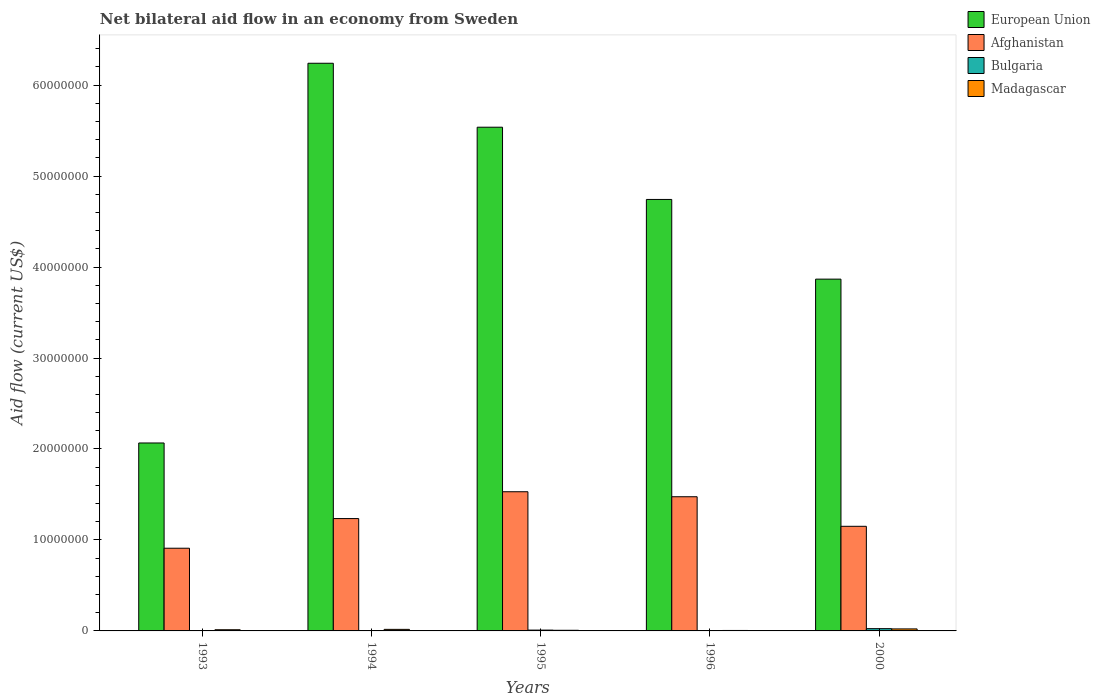Are the number of bars per tick equal to the number of legend labels?
Your answer should be very brief. Yes. How many bars are there on the 1st tick from the right?
Provide a short and direct response. 4. Across all years, what is the minimum net bilateral aid flow in Bulgaria?
Make the answer very short. 10000. In which year was the net bilateral aid flow in European Union maximum?
Offer a very short reply. 1994. What is the total net bilateral aid flow in Afghanistan in the graph?
Ensure brevity in your answer.  6.30e+07. What is the difference between the net bilateral aid flow in Bulgaria in 1994 and that in 2000?
Keep it short and to the point. -2.30e+05. What is the difference between the net bilateral aid flow in European Union in 1993 and the net bilateral aid flow in Bulgaria in 1994?
Offer a very short reply. 2.06e+07. What is the average net bilateral aid flow in Afghanistan per year?
Your answer should be very brief. 1.26e+07. In the year 1994, what is the difference between the net bilateral aid flow in European Union and net bilateral aid flow in Afghanistan?
Give a very brief answer. 5.00e+07. In how many years, is the net bilateral aid flow in Bulgaria greater than 52000000 US$?
Offer a terse response. 0. What is the ratio of the net bilateral aid flow in Madagascar in 1994 to that in 1996?
Your answer should be very brief. 3.4. Is the net bilateral aid flow in European Union in 1994 less than that in 1995?
Your answer should be very brief. No. Is the difference between the net bilateral aid flow in European Union in 1994 and 1996 greater than the difference between the net bilateral aid flow in Afghanistan in 1994 and 1996?
Offer a very short reply. Yes. What is the difference between the highest and the second highest net bilateral aid flow in European Union?
Offer a very short reply. 7.03e+06. What is the difference between the highest and the lowest net bilateral aid flow in Afghanistan?
Your answer should be very brief. 6.21e+06. In how many years, is the net bilateral aid flow in European Union greater than the average net bilateral aid flow in European Union taken over all years?
Ensure brevity in your answer.  3. Is it the case that in every year, the sum of the net bilateral aid flow in Bulgaria and net bilateral aid flow in Afghanistan is greater than the sum of net bilateral aid flow in Madagascar and net bilateral aid flow in European Union?
Your answer should be very brief. No. What does the 2nd bar from the left in 1994 represents?
Make the answer very short. Afghanistan. Are all the bars in the graph horizontal?
Give a very brief answer. No. Where does the legend appear in the graph?
Provide a short and direct response. Top right. How many legend labels are there?
Provide a short and direct response. 4. How are the legend labels stacked?
Your response must be concise. Vertical. What is the title of the graph?
Your answer should be very brief. Net bilateral aid flow in an economy from Sweden. What is the label or title of the X-axis?
Offer a terse response. Years. What is the label or title of the Y-axis?
Ensure brevity in your answer.  Aid flow (current US$). What is the Aid flow (current US$) of European Union in 1993?
Your response must be concise. 2.07e+07. What is the Aid flow (current US$) in Afghanistan in 1993?
Provide a succinct answer. 9.09e+06. What is the Aid flow (current US$) of Bulgaria in 1993?
Provide a short and direct response. 10000. What is the Aid flow (current US$) of Madagascar in 1993?
Your answer should be very brief. 1.30e+05. What is the Aid flow (current US$) of European Union in 1994?
Keep it short and to the point. 6.24e+07. What is the Aid flow (current US$) of Afghanistan in 1994?
Offer a terse response. 1.24e+07. What is the Aid flow (current US$) of European Union in 1995?
Make the answer very short. 5.54e+07. What is the Aid flow (current US$) of Afghanistan in 1995?
Keep it short and to the point. 1.53e+07. What is the Aid flow (current US$) of Madagascar in 1995?
Make the answer very short. 7.00e+04. What is the Aid flow (current US$) in European Union in 1996?
Your answer should be very brief. 4.74e+07. What is the Aid flow (current US$) in Afghanistan in 1996?
Make the answer very short. 1.48e+07. What is the Aid flow (current US$) in Madagascar in 1996?
Ensure brevity in your answer.  5.00e+04. What is the Aid flow (current US$) of European Union in 2000?
Give a very brief answer. 3.87e+07. What is the Aid flow (current US$) of Afghanistan in 2000?
Provide a short and direct response. 1.15e+07. What is the Aid flow (current US$) in Madagascar in 2000?
Give a very brief answer. 2.20e+05. Across all years, what is the maximum Aid flow (current US$) in European Union?
Give a very brief answer. 6.24e+07. Across all years, what is the maximum Aid flow (current US$) of Afghanistan?
Give a very brief answer. 1.53e+07. Across all years, what is the maximum Aid flow (current US$) in Bulgaria?
Give a very brief answer. 2.50e+05. Across all years, what is the minimum Aid flow (current US$) in European Union?
Your answer should be very brief. 2.07e+07. Across all years, what is the minimum Aid flow (current US$) of Afghanistan?
Give a very brief answer. 9.09e+06. Across all years, what is the minimum Aid flow (current US$) of Bulgaria?
Provide a succinct answer. 10000. Across all years, what is the minimum Aid flow (current US$) of Madagascar?
Provide a short and direct response. 5.00e+04. What is the total Aid flow (current US$) in European Union in the graph?
Offer a terse response. 2.25e+08. What is the total Aid flow (current US$) of Afghanistan in the graph?
Keep it short and to the point. 6.30e+07. What is the total Aid flow (current US$) in Madagascar in the graph?
Offer a terse response. 6.40e+05. What is the difference between the Aid flow (current US$) of European Union in 1993 and that in 1994?
Your answer should be compact. -4.17e+07. What is the difference between the Aid flow (current US$) in Afghanistan in 1993 and that in 1994?
Your response must be concise. -3.26e+06. What is the difference between the Aid flow (current US$) of Bulgaria in 1993 and that in 1994?
Your answer should be compact. -10000. What is the difference between the Aid flow (current US$) of Madagascar in 1993 and that in 1994?
Offer a very short reply. -4.00e+04. What is the difference between the Aid flow (current US$) in European Union in 1993 and that in 1995?
Your answer should be very brief. -3.47e+07. What is the difference between the Aid flow (current US$) of Afghanistan in 1993 and that in 1995?
Keep it short and to the point. -6.21e+06. What is the difference between the Aid flow (current US$) of Madagascar in 1993 and that in 1995?
Your answer should be very brief. 6.00e+04. What is the difference between the Aid flow (current US$) in European Union in 1993 and that in 1996?
Provide a short and direct response. -2.68e+07. What is the difference between the Aid flow (current US$) in Afghanistan in 1993 and that in 1996?
Provide a short and direct response. -5.66e+06. What is the difference between the Aid flow (current US$) of Bulgaria in 1993 and that in 1996?
Offer a very short reply. 0. What is the difference between the Aid flow (current US$) in European Union in 1993 and that in 2000?
Ensure brevity in your answer.  -1.80e+07. What is the difference between the Aid flow (current US$) of Afghanistan in 1993 and that in 2000?
Offer a terse response. -2.41e+06. What is the difference between the Aid flow (current US$) of Bulgaria in 1993 and that in 2000?
Your answer should be compact. -2.40e+05. What is the difference between the Aid flow (current US$) in Madagascar in 1993 and that in 2000?
Give a very brief answer. -9.00e+04. What is the difference between the Aid flow (current US$) in European Union in 1994 and that in 1995?
Your response must be concise. 7.03e+06. What is the difference between the Aid flow (current US$) in Afghanistan in 1994 and that in 1995?
Your answer should be compact. -2.95e+06. What is the difference between the Aid flow (current US$) of Bulgaria in 1994 and that in 1995?
Provide a short and direct response. -7.00e+04. What is the difference between the Aid flow (current US$) in European Union in 1994 and that in 1996?
Your answer should be compact. 1.50e+07. What is the difference between the Aid flow (current US$) of Afghanistan in 1994 and that in 1996?
Provide a short and direct response. -2.40e+06. What is the difference between the Aid flow (current US$) in Bulgaria in 1994 and that in 1996?
Your answer should be compact. 10000. What is the difference between the Aid flow (current US$) in Madagascar in 1994 and that in 1996?
Keep it short and to the point. 1.20e+05. What is the difference between the Aid flow (current US$) in European Union in 1994 and that in 2000?
Your response must be concise. 2.37e+07. What is the difference between the Aid flow (current US$) in Afghanistan in 1994 and that in 2000?
Provide a short and direct response. 8.50e+05. What is the difference between the Aid flow (current US$) of Bulgaria in 1994 and that in 2000?
Your response must be concise. -2.30e+05. What is the difference between the Aid flow (current US$) in European Union in 1995 and that in 1996?
Provide a succinct answer. 7.94e+06. What is the difference between the Aid flow (current US$) of Madagascar in 1995 and that in 1996?
Offer a very short reply. 2.00e+04. What is the difference between the Aid flow (current US$) of European Union in 1995 and that in 2000?
Ensure brevity in your answer.  1.67e+07. What is the difference between the Aid flow (current US$) of Afghanistan in 1995 and that in 2000?
Provide a succinct answer. 3.80e+06. What is the difference between the Aid flow (current US$) of Bulgaria in 1995 and that in 2000?
Provide a succinct answer. -1.60e+05. What is the difference between the Aid flow (current US$) of Madagascar in 1995 and that in 2000?
Your answer should be very brief. -1.50e+05. What is the difference between the Aid flow (current US$) in European Union in 1996 and that in 2000?
Provide a short and direct response. 8.76e+06. What is the difference between the Aid flow (current US$) of Afghanistan in 1996 and that in 2000?
Give a very brief answer. 3.25e+06. What is the difference between the Aid flow (current US$) of European Union in 1993 and the Aid flow (current US$) of Afghanistan in 1994?
Make the answer very short. 8.31e+06. What is the difference between the Aid flow (current US$) in European Union in 1993 and the Aid flow (current US$) in Bulgaria in 1994?
Your answer should be compact. 2.06e+07. What is the difference between the Aid flow (current US$) of European Union in 1993 and the Aid flow (current US$) of Madagascar in 1994?
Your answer should be very brief. 2.05e+07. What is the difference between the Aid flow (current US$) of Afghanistan in 1993 and the Aid flow (current US$) of Bulgaria in 1994?
Provide a succinct answer. 9.07e+06. What is the difference between the Aid flow (current US$) in Afghanistan in 1993 and the Aid flow (current US$) in Madagascar in 1994?
Make the answer very short. 8.92e+06. What is the difference between the Aid flow (current US$) of Bulgaria in 1993 and the Aid flow (current US$) of Madagascar in 1994?
Offer a very short reply. -1.60e+05. What is the difference between the Aid flow (current US$) of European Union in 1993 and the Aid flow (current US$) of Afghanistan in 1995?
Your answer should be very brief. 5.36e+06. What is the difference between the Aid flow (current US$) in European Union in 1993 and the Aid flow (current US$) in Bulgaria in 1995?
Give a very brief answer. 2.06e+07. What is the difference between the Aid flow (current US$) of European Union in 1993 and the Aid flow (current US$) of Madagascar in 1995?
Offer a very short reply. 2.06e+07. What is the difference between the Aid flow (current US$) of Afghanistan in 1993 and the Aid flow (current US$) of Bulgaria in 1995?
Give a very brief answer. 9.00e+06. What is the difference between the Aid flow (current US$) in Afghanistan in 1993 and the Aid flow (current US$) in Madagascar in 1995?
Ensure brevity in your answer.  9.02e+06. What is the difference between the Aid flow (current US$) in Bulgaria in 1993 and the Aid flow (current US$) in Madagascar in 1995?
Your response must be concise. -6.00e+04. What is the difference between the Aid flow (current US$) in European Union in 1993 and the Aid flow (current US$) in Afghanistan in 1996?
Your answer should be compact. 5.91e+06. What is the difference between the Aid flow (current US$) in European Union in 1993 and the Aid flow (current US$) in Bulgaria in 1996?
Your answer should be very brief. 2.06e+07. What is the difference between the Aid flow (current US$) in European Union in 1993 and the Aid flow (current US$) in Madagascar in 1996?
Make the answer very short. 2.06e+07. What is the difference between the Aid flow (current US$) of Afghanistan in 1993 and the Aid flow (current US$) of Bulgaria in 1996?
Provide a succinct answer. 9.08e+06. What is the difference between the Aid flow (current US$) in Afghanistan in 1993 and the Aid flow (current US$) in Madagascar in 1996?
Offer a very short reply. 9.04e+06. What is the difference between the Aid flow (current US$) of Bulgaria in 1993 and the Aid flow (current US$) of Madagascar in 1996?
Ensure brevity in your answer.  -4.00e+04. What is the difference between the Aid flow (current US$) in European Union in 1993 and the Aid flow (current US$) in Afghanistan in 2000?
Your answer should be very brief. 9.16e+06. What is the difference between the Aid flow (current US$) of European Union in 1993 and the Aid flow (current US$) of Bulgaria in 2000?
Provide a short and direct response. 2.04e+07. What is the difference between the Aid flow (current US$) in European Union in 1993 and the Aid flow (current US$) in Madagascar in 2000?
Your answer should be compact. 2.04e+07. What is the difference between the Aid flow (current US$) of Afghanistan in 1993 and the Aid flow (current US$) of Bulgaria in 2000?
Make the answer very short. 8.84e+06. What is the difference between the Aid flow (current US$) of Afghanistan in 1993 and the Aid flow (current US$) of Madagascar in 2000?
Your response must be concise. 8.87e+06. What is the difference between the Aid flow (current US$) of European Union in 1994 and the Aid flow (current US$) of Afghanistan in 1995?
Keep it short and to the point. 4.71e+07. What is the difference between the Aid flow (current US$) in European Union in 1994 and the Aid flow (current US$) in Bulgaria in 1995?
Offer a terse response. 6.23e+07. What is the difference between the Aid flow (current US$) of European Union in 1994 and the Aid flow (current US$) of Madagascar in 1995?
Your answer should be compact. 6.23e+07. What is the difference between the Aid flow (current US$) of Afghanistan in 1994 and the Aid flow (current US$) of Bulgaria in 1995?
Keep it short and to the point. 1.23e+07. What is the difference between the Aid flow (current US$) in Afghanistan in 1994 and the Aid flow (current US$) in Madagascar in 1995?
Your answer should be very brief. 1.23e+07. What is the difference between the Aid flow (current US$) of European Union in 1994 and the Aid flow (current US$) of Afghanistan in 1996?
Provide a succinct answer. 4.76e+07. What is the difference between the Aid flow (current US$) in European Union in 1994 and the Aid flow (current US$) in Bulgaria in 1996?
Offer a very short reply. 6.24e+07. What is the difference between the Aid flow (current US$) in European Union in 1994 and the Aid flow (current US$) in Madagascar in 1996?
Your answer should be compact. 6.24e+07. What is the difference between the Aid flow (current US$) in Afghanistan in 1994 and the Aid flow (current US$) in Bulgaria in 1996?
Provide a succinct answer. 1.23e+07. What is the difference between the Aid flow (current US$) in Afghanistan in 1994 and the Aid flow (current US$) in Madagascar in 1996?
Offer a very short reply. 1.23e+07. What is the difference between the Aid flow (current US$) of Bulgaria in 1994 and the Aid flow (current US$) of Madagascar in 1996?
Offer a terse response. -3.00e+04. What is the difference between the Aid flow (current US$) of European Union in 1994 and the Aid flow (current US$) of Afghanistan in 2000?
Give a very brief answer. 5.09e+07. What is the difference between the Aid flow (current US$) in European Union in 1994 and the Aid flow (current US$) in Bulgaria in 2000?
Your answer should be compact. 6.22e+07. What is the difference between the Aid flow (current US$) of European Union in 1994 and the Aid flow (current US$) of Madagascar in 2000?
Provide a succinct answer. 6.22e+07. What is the difference between the Aid flow (current US$) in Afghanistan in 1994 and the Aid flow (current US$) in Bulgaria in 2000?
Keep it short and to the point. 1.21e+07. What is the difference between the Aid flow (current US$) in Afghanistan in 1994 and the Aid flow (current US$) in Madagascar in 2000?
Ensure brevity in your answer.  1.21e+07. What is the difference between the Aid flow (current US$) in European Union in 1995 and the Aid flow (current US$) in Afghanistan in 1996?
Provide a succinct answer. 4.06e+07. What is the difference between the Aid flow (current US$) of European Union in 1995 and the Aid flow (current US$) of Bulgaria in 1996?
Your response must be concise. 5.54e+07. What is the difference between the Aid flow (current US$) of European Union in 1995 and the Aid flow (current US$) of Madagascar in 1996?
Your response must be concise. 5.53e+07. What is the difference between the Aid flow (current US$) of Afghanistan in 1995 and the Aid flow (current US$) of Bulgaria in 1996?
Offer a very short reply. 1.53e+07. What is the difference between the Aid flow (current US$) in Afghanistan in 1995 and the Aid flow (current US$) in Madagascar in 1996?
Your response must be concise. 1.52e+07. What is the difference between the Aid flow (current US$) of European Union in 1995 and the Aid flow (current US$) of Afghanistan in 2000?
Ensure brevity in your answer.  4.39e+07. What is the difference between the Aid flow (current US$) in European Union in 1995 and the Aid flow (current US$) in Bulgaria in 2000?
Make the answer very short. 5.51e+07. What is the difference between the Aid flow (current US$) of European Union in 1995 and the Aid flow (current US$) of Madagascar in 2000?
Give a very brief answer. 5.52e+07. What is the difference between the Aid flow (current US$) in Afghanistan in 1995 and the Aid flow (current US$) in Bulgaria in 2000?
Provide a succinct answer. 1.50e+07. What is the difference between the Aid flow (current US$) in Afghanistan in 1995 and the Aid flow (current US$) in Madagascar in 2000?
Your answer should be compact. 1.51e+07. What is the difference between the Aid flow (current US$) of European Union in 1996 and the Aid flow (current US$) of Afghanistan in 2000?
Provide a succinct answer. 3.59e+07. What is the difference between the Aid flow (current US$) in European Union in 1996 and the Aid flow (current US$) in Bulgaria in 2000?
Ensure brevity in your answer.  4.72e+07. What is the difference between the Aid flow (current US$) of European Union in 1996 and the Aid flow (current US$) of Madagascar in 2000?
Offer a very short reply. 4.72e+07. What is the difference between the Aid flow (current US$) in Afghanistan in 1996 and the Aid flow (current US$) in Bulgaria in 2000?
Give a very brief answer. 1.45e+07. What is the difference between the Aid flow (current US$) of Afghanistan in 1996 and the Aid flow (current US$) of Madagascar in 2000?
Keep it short and to the point. 1.45e+07. What is the difference between the Aid flow (current US$) of Bulgaria in 1996 and the Aid flow (current US$) of Madagascar in 2000?
Offer a terse response. -2.10e+05. What is the average Aid flow (current US$) in European Union per year?
Offer a terse response. 4.49e+07. What is the average Aid flow (current US$) of Afghanistan per year?
Provide a short and direct response. 1.26e+07. What is the average Aid flow (current US$) of Bulgaria per year?
Ensure brevity in your answer.  7.60e+04. What is the average Aid flow (current US$) in Madagascar per year?
Provide a short and direct response. 1.28e+05. In the year 1993, what is the difference between the Aid flow (current US$) in European Union and Aid flow (current US$) in Afghanistan?
Make the answer very short. 1.16e+07. In the year 1993, what is the difference between the Aid flow (current US$) in European Union and Aid flow (current US$) in Bulgaria?
Your answer should be very brief. 2.06e+07. In the year 1993, what is the difference between the Aid flow (current US$) in European Union and Aid flow (current US$) in Madagascar?
Your answer should be compact. 2.05e+07. In the year 1993, what is the difference between the Aid flow (current US$) in Afghanistan and Aid flow (current US$) in Bulgaria?
Provide a short and direct response. 9.08e+06. In the year 1993, what is the difference between the Aid flow (current US$) of Afghanistan and Aid flow (current US$) of Madagascar?
Offer a terse response. 8.96e+06. In the year 1994, what is the difference between the Aid flow (current US$) of European Union and Aid flow (current US$) of Afghanistan?
Ensure brevity in your answer.  5.00e+07. In the year 1994, what is the difference between the Aid flow (current US$) in European Union and Aid flow (current US$) in Bulgaria?
Provide a short and direct response. 6.24e+07. In the year 1994, what is the difference between the Aid flow (current US$) in European Union and Aid flow (current US$) in Madagascar?
Your answer should be very brief. 6.22e+07. In the year 1994, what is the difference between the Aid flow (current US$) of Afghanistan and Aid flow (current US$) of Bulgaria?
Provide a succinct answer. 1.23e+07. In the year 1994, what is the difference between the Aid flow (current US$) in Afghanistan and Aid flow (current US$) in Madagascar?
Give a very brief answer. 1.22e+07. In the year 1994, what is the difference between the Aid flow (current US$) in Bulgaria and Aid flow (current US$) in Madagascar?
Keep it short and to the point. -1.50e+05. In the year 1995, what is the difference between the Aid flow (current US$) of European Union and Aid flow (current US$) of Afghanistan?
Ensure brevity in your answer.  4.01e+07. In the year 1995, what is the difference between the Aid flow (current US$) of European Union and Aid flow (current US$) of Bulgaria?
Give a very brief answer. 5.53e+07. In the year 1995, what is the difference between the Aid flow (current US$) of European Union and Aid flow (current US$) of Madagascar?
Your response must be concise. 5.53e+07. In the year 1995, what is the difference between the Aid flow (current US$) in Afghanistan and Aid flow (current US$) in Bulgaria?
Your answer should be very brief. 1.52e+07. In the year 1995, what is the difference between the Aid flow (current US$) in Afghanistan and Aid flow (current US$) in Madagascar?
Your answer should be compact. 1.52e+07. In the year 1996, what is the difference between the Aid flow (current US$) of European Union and Aid flow (current US$) of Afghanistan?
Give a very brief answer. 3.27e+07. In the year 1996, what is the difference between the Aid flow (current US$) of European Union and Aid flow (current US$) of Bulgaria?
Your answer should be very brief. 4.74e+07. In the year 1996, what is the difference between the Aid flow (current US$) in European Union and Aid flow (current US$) in Madagascar?
Your answer should be compact. 4.74e+07. In the year 1996, what is the difference between the Aid flow (current US$) of Afghanistan and Aid flow (current US$) of Bulgaria?
Offer a terse response. 1.47e+07. In the year 1996, what is the difference between the Aid flow (current US$) of Afghanistan and Aid flow (current US$) of Madagascar?
Provide a succinct answer. 1.47e+07. In the year 1996, what is the difference between the Aid flow (current US$) of Bulgaria and Aid flow (current US$) of Madagascar?
Offer a very short reply. -4.00e+04. In the year 2000, what is the difference between the Aid flow (current US$) in European Union and Aid flow (current US$) in Afghanistan?
Provide a short and direct response. 2.72e+07. In the year 2000, what is the difference between the Aid flow (current US$) in European Union and Aid flow (current US$) in Bulgaria?
Your answer should be very brief. 3.84e+07. In the year 2000, what is the difference between the Aid flow (current US$) of European Union and Aid flow (current US$) of Madagascar?
Provide a succinct answer. 3.84e+07. In the year 2000, what is the difference between the Aid flow (current US$) of Afghanistan and Aid flow (current US$) of Bulgaria?
Your answer should be very brief. 1.12e+07. In the year 2000, what is the difference between the Aid flow (current US$) of Afghanistan and Aid flow (current US$) of Madagascar?
Ensure brevity in your answer.  1.13e+07. In the year 2000, what is the difference between the Aid flow (current US$) of Bulgaria and Aid flow (current US$) of Madagascar?
Ensure brevity in your answer.  3.00e+04. What is the ratio of the Aid flow (current US$) of European Union in 1993 to that in 1994?
Keep it short and to the point. 0.33. What is the ratio of the Aid flow (current US$) of Afghanistan in 1993 to that in 1994?
Provide a succinct answer. 0.74. What is the ratio of the Aid flow (current US$) in Madagascar in 1993 to that in 1994?
Your answer should be very brief. 0.76. What is the ratio of the Aid flow (current US$) in European Union in 1993 to that in 1995?
Offer a terse response. 0.37. What is the ratio of the Aid flow (current US$) of Afghanistan in 1993 to that in 1995?
Give a very brief answer. 0.59. What is the ratio of the Aid flow (current US$) of Bulgaria in 1993 to that in 1995?
Your answer should be very brief. 0.11. What is the ratio of the Aid flow (current US$) of Madagascar in 1993 to that in 1995?
Offer a terse response. 1.86. What is the ratio of the Aid flow (current US$) in European Union in 1993 to that in 1996?
Your answer should be compact. 0.44. What is the ratio of the Aid flow (current US$) in Afghanistan in 1993 to that in 1996?
Your response must be concise. 0.62. What is the ratio of the Aid flow (current US$) in Bulgaria in 1993 to that in 1996?
Ensure brevity in your answer.  1. What is the ratio of the Aid flow (current US$) of European Union in 1993 to that in 2000?
Make the answer very short. 0.53. What is the ratio of the Aid flow (current US$) of Afghanistan in 1993 to that in 2000?
Your response must be concise. 0.79. What is the ratio of the Aid flow (current US$) of Madagascar in 1993 to that in 2000?
Offer a terse response. 0.59. What is the ratio of the Aid flow (current US$) in European Union in 1994 to that in 1995?
Keep it short and to the point. 1.13. What is the ratio of the Aid flow (current US$) of Afghanistan in 1994 to that in 1995?
Your response must be concise. 0.81. What is the ratio of the Aid flow (current US$) of Bulgaria in 1994 to that in 1995?
Give a very brief answer. 0.22. What is the ratio of the Aid flow (current US$) in Madagascar in 1994 to that in 1995?
Provide a succinct answer. 2.43. What is the ratio of the Aid flow (current US$) in European Union in 1994 to that in 1996?
Offer a very short reply. 1.32. What is the ratio of the Aid flow (current US$) of Afghanistan in 1994 to that in 1996?
Your answer should be compact. 0.84. What is the ratio of the Aid flow (current US$) of Bulgaria in 1994 to that in 1996?
Your response must be concise. 2. What is the ratio of the Aid flow (current US$) of Madagascar in 1994 to that in 1996?
Keep it short and to the point. 3.4. What is the ratio of the Aid flow (current US$) of European Union in 1994 to that in 2000?
Provide a succinct answer. 1.61. What is the ratio of the Aid flow (current US$) of Afghanistan in 1994 to that in 2000?
Provide a short and direct response. 1.07. What is the ratio of the Aid flow (current US$) of Madagascar in 1994 to that in 2000?
Your answer should be very brief. 0.77. What is the ratio of the Aid flow (current US$) of European Union in 1995 to that in 1996?
Keep it short and to the point. 1.17. What is the ratio of the Aid flow (current US$) of Afghanistan in 1995 to that in 1996?
Your response must be concise. 1.04. What is the ratio of the Aid flow (current US$) of European Union in 1995 to that in 2000?
Your response must be concise. 1.43. What is the ratio of the Aid flow (current US$) in Afghanistan in 1995 to that in 2000?
Offer a very short reply. 1.33. What is the ratio of the Aid flow (current US$) of Bulgaria in 1995 to that in 2000?
Offer a terse response. 0.36. What is the ratio of the Aid flow (current US$) in Madagascar in 1995 to that in 2000?
Make the answer very short. 0.32. What is the ratio of the Aid flow (current US$) in European Union in 1996 to that in 2000?
Provide a short and direct response. 1.23. What is the ratio of the Aid flow (current US$) of Afghanistan in 1996 to that in 2000?
Ensure brevity in your answer.  1.28. What is the ratio of the Aid flow (current US$) in Bulgaria in 1996 to that in 2000?
Offer a very short reply. 0.04. What is the ratio of the Aid flow (current US$) in Madagascar in 1996 to that in 2000?
Ensure brevity in your answer.  0.23. What is the difference between the highest and the second highest Aid flow (current US$) of European Union?
Offer a very short reply. 7.03e+06. What is the difference between the highest and the second highest Aid flow (current US$) in Afghanistan?
Provide a succinct answer. 5.50e+05. What is the difference between the highest and the lowest Aid flow (current US$) in European Union?
Provide a short and direct response. 4.17e+07. What is the difference between the highest and the lowest Aid flow (current US$) of Afghanistan?
Offer a terse response. 6.21e+06. What is the difference between the highest and the lowest Aid flow (current US$) in Bulgaria?
Offer a very short reply. 2.40e+05. What is the difference between the highest and the lowest Aid flow (current US$) of Madagascar?
Provide a short and direct response. 1.70e+05. 